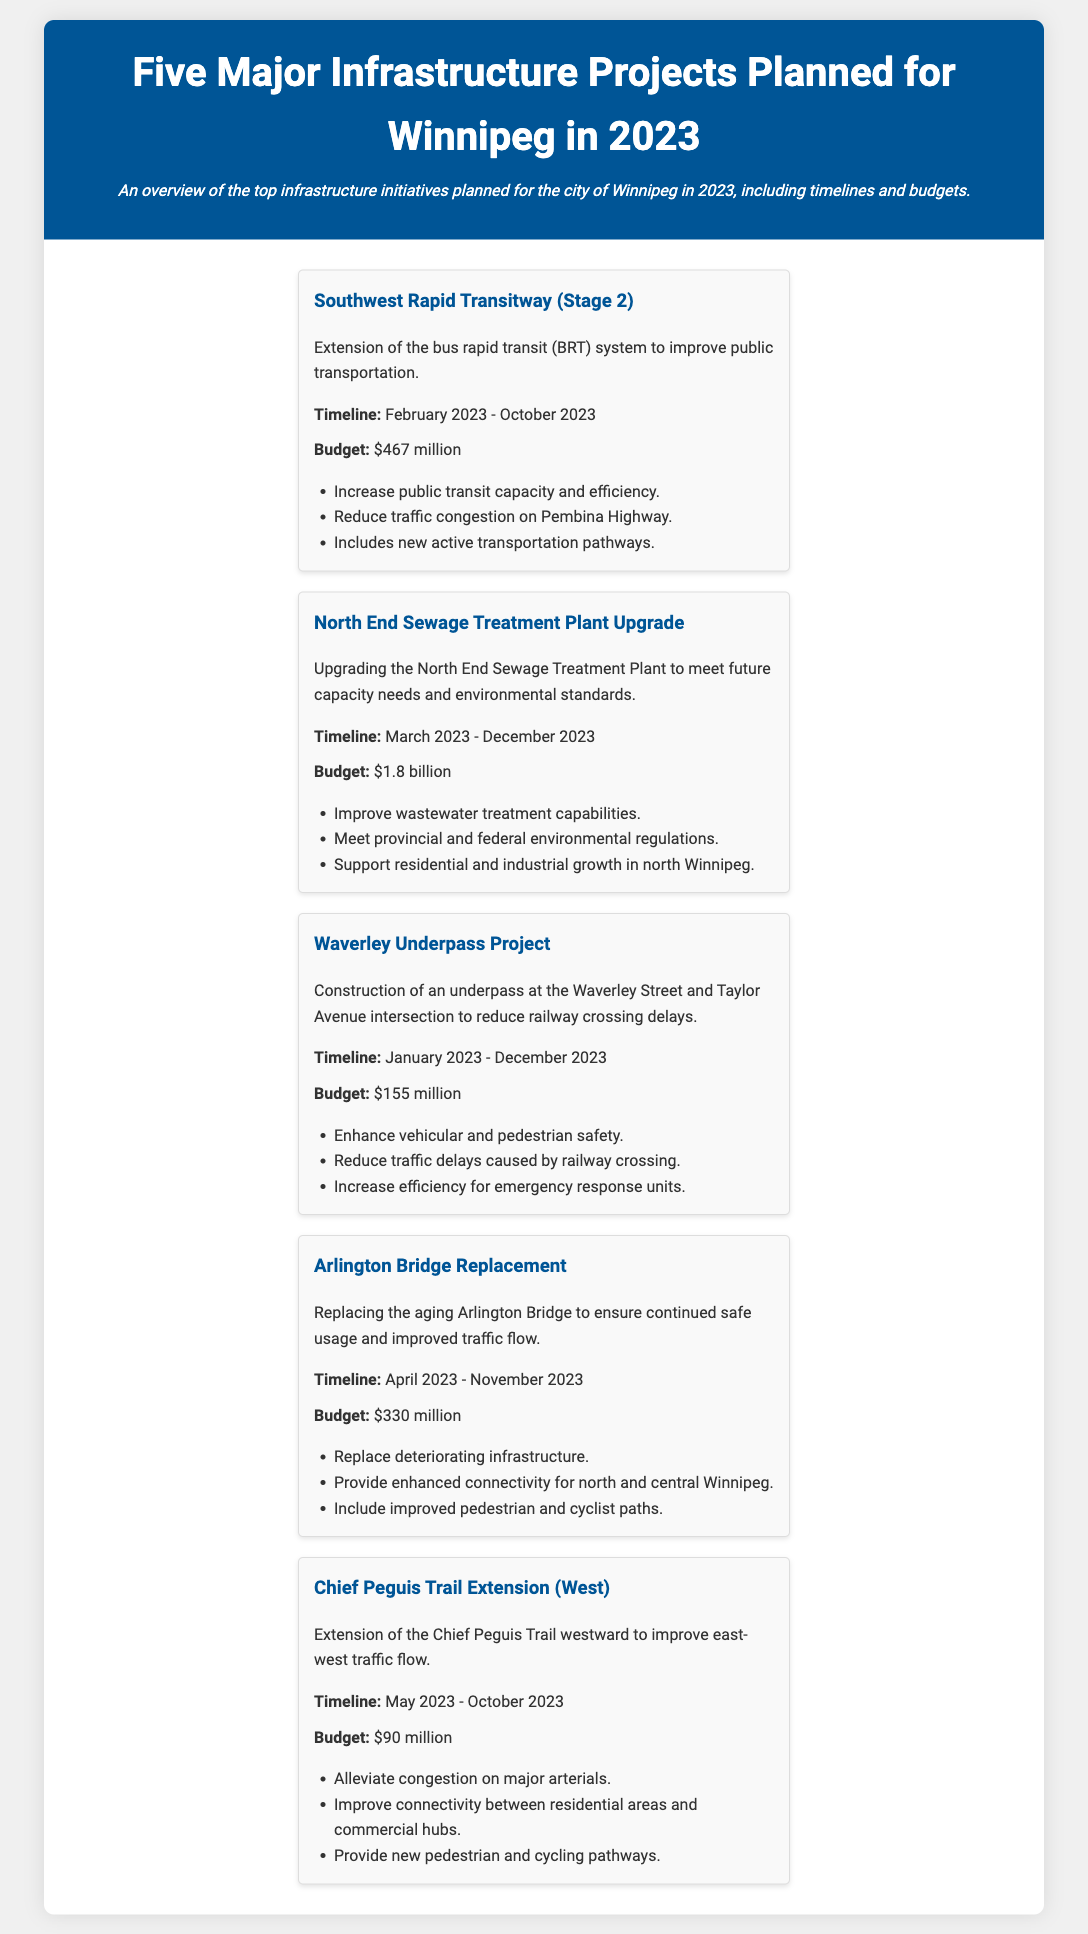What is the budget for the North End Sewage Treatment Plant Upgrade? The budget for the North End Sewage Treatment Plant Upgrade is clearly stated in the document.
Answer: $1.8 billion When does the Southwest Rapid Transitway (Stage 2) project start? The timeline for the Southwest Rapid Transitway (Stage 2) project indicates the starting date within the document.
Answer: February 2023 What is the main goal of the Waverley Underpass Project? The document outlines specific goals for each project, including reducing railway crossing delays for the Waverley Underpass Project.
Answer: Reduce railway crossing delays How much is allocated for the Arlington Bridge Replacement? The budget for the Arlington Bridge Replacement project is listed in the budget section of the document.
Answer: $330 million Which project aims to improve east-west traffic flow? The document names infrastructure projects, and one of them is specifically aimed at improving east-west traffic flow.
Answer: Chief Peguis Trail Extension (West) What is the completion date for the Chief Peguis Trail Extension (West)? The timeline mentioned in the document provides the expected completion date for the Chief Peguis Trail Extension (West).
Answer: October 2023 How many projects have a timeline that extends into December 2023? The count of projects with timelines is detailed in the document and requires assessing the timelines of all projects listed.
Answer: 2 What feature is included in the Southwest Rapid Transitway (Stage 2)? The document details features included in the Southwest Rapid Transitway (Stage 2) project.
Answer: New active transportation pathways 